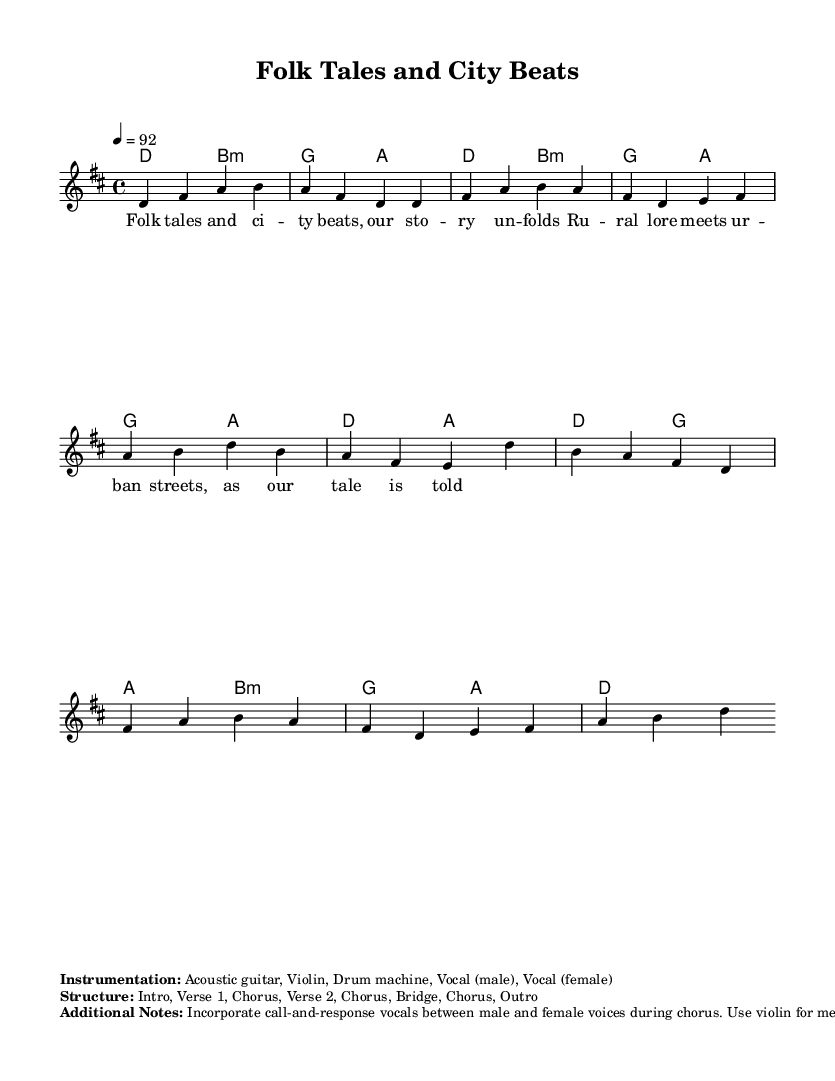what is the key signature of this music? The key signature in the sheet music is indicated by the `\key d \major` command, which shows that the piece is in D major.
Answer: D major what is the time signature of this music? The time signature is indicated by the `\time 4/4` command, which signifies that there are four beats in each measure and a quarter note gets one beat.
Answer: 4/4 what is the tempo marking for this piece? The tempo is indicated by the `\tempo 4 = 92`, which means the piece should be played at a speed of 92 beats per minute (BPM).
Answer: 92 how many sections are there in the structure of the music? The structure is detailed in the markup where it lists “Intro, Verse 1, Chorus, Verse 2, Chorus, Bridge, Chorus, Outro.” Counting these, we find there are eight sections in total.
Answer: 8 what instruments are specified for this music? The instrumentation is noted in the markup section which states "Acoustic guitar, Violin, Drum machine, Vocal (male), Vocal (female)." This indicates the use of these five instruments.
Answer: Acoustic guitar, Violin, Drum machine, Vocal (male), Vocal (female) how does the chorus incorporate vocal interaction? The additional notes imply that there is a "call-and-response" interaction between male and female vocals during the chorus, highlighting a distinctive feature that enhances the melodic rap style.
Answer: Call-and-response what style of storytelling does this music represent? The lyrics and structure suggest a blend of folk-style storytelling with urban themes, which aligns with the characteristics of melodic rap combining narrative and rhythm.
Answer: Folk-style storytelling 